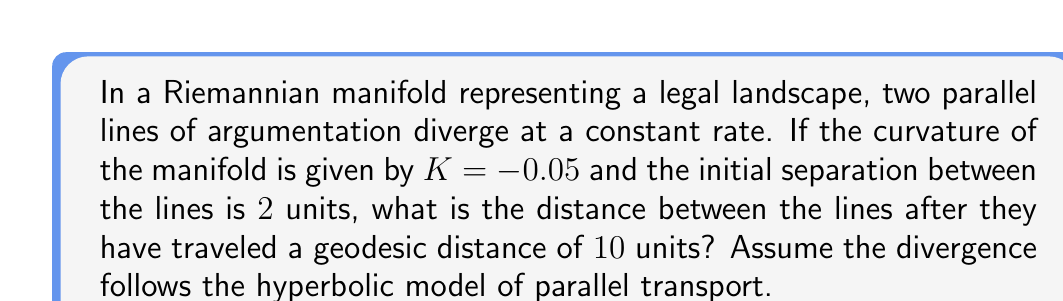Could you help me with this problem? To solve this problem, we'll use the hyperbolic model of parallel transport in a negatively curved Riemannian manifold. The formula for the distance between two initially parallel geodesics in this model is:

$$d(s) = d_0 \cosh(\sqrt{-K}s)$$

Where:
- $d(s)$ is the distance between the geodesics after traveling a distance $s$
- $d_0$ is the initial separation
- $K$ is the curvature of the manifold
- $s$ is the geodesic distance traveled

Given:
- $K = -0.05$
- $d_0 = 2$ units
- $s = 10$ units

Step 1: Substitute the values into the formula:
$$d(10) = 2 \cosh(\sqrt{0.05} \cdot 10)$$

Step 2: Simplify the expression inside the cosh function:
$$d(10) = 2 \cosh(\sqrt{0.05} \cdot 10) = 2 \cosh(\sqrt{0.5})$$

Step 3: Calculate the value of $\cosh(\sqrt{0.5})$:
$$\cosh(\sqrt{0.5}) \approx 1.2707$$

Step 4: Multiply by the initial separation:
$$d(10) = 2 \cdot 1.2707 \approx 2.5414$$

Therefore, the distance between the lines after traveling 10 units is approximately 2.5414 units.
Answer: $2.5414$ units 